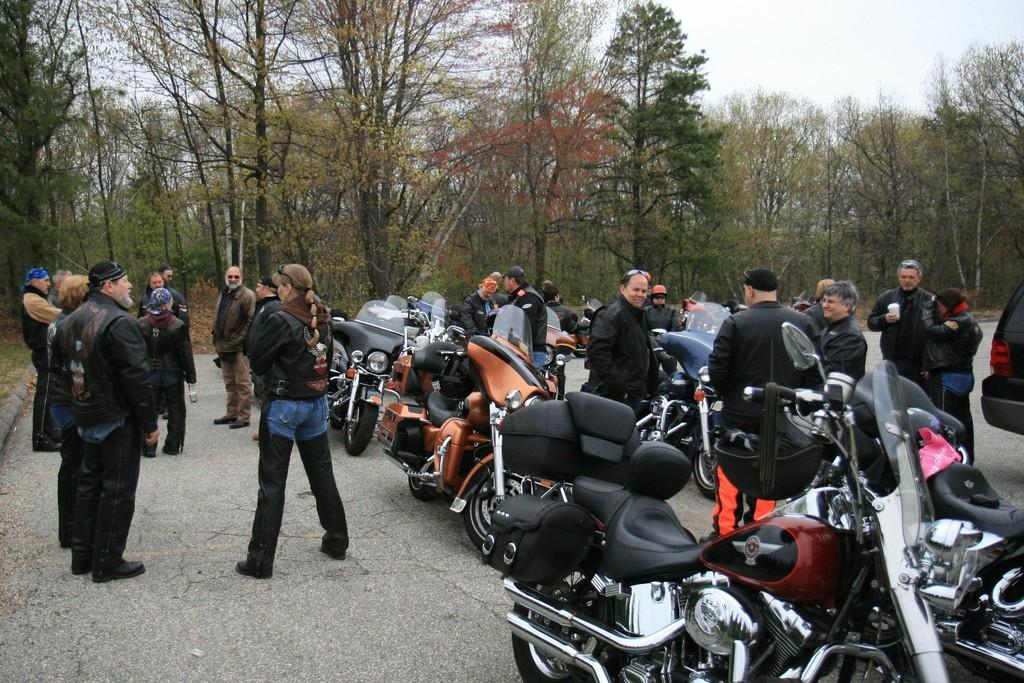How many people are present in the image? There are many people in the image. What are some people wearing on their heads? Some people are wearing caps in the image. What type of vehicles can be seen in the image? There are motorcycles in the image. What can be seen in the background of the image? Trees are visible in the background of the image. What part of the natural environment is visible in the image? The sky is visible in the image. What type of toothbrush is being used by the person on the motorcycle in the image? There is no toothbrush visible in the image, and no person is shown using one. How does the control of the motorcycles affect the movement of the people in the image? The control of the motorcycles is not mentioned in the image, and there is no direct correlation between the control and the movement of the people. 